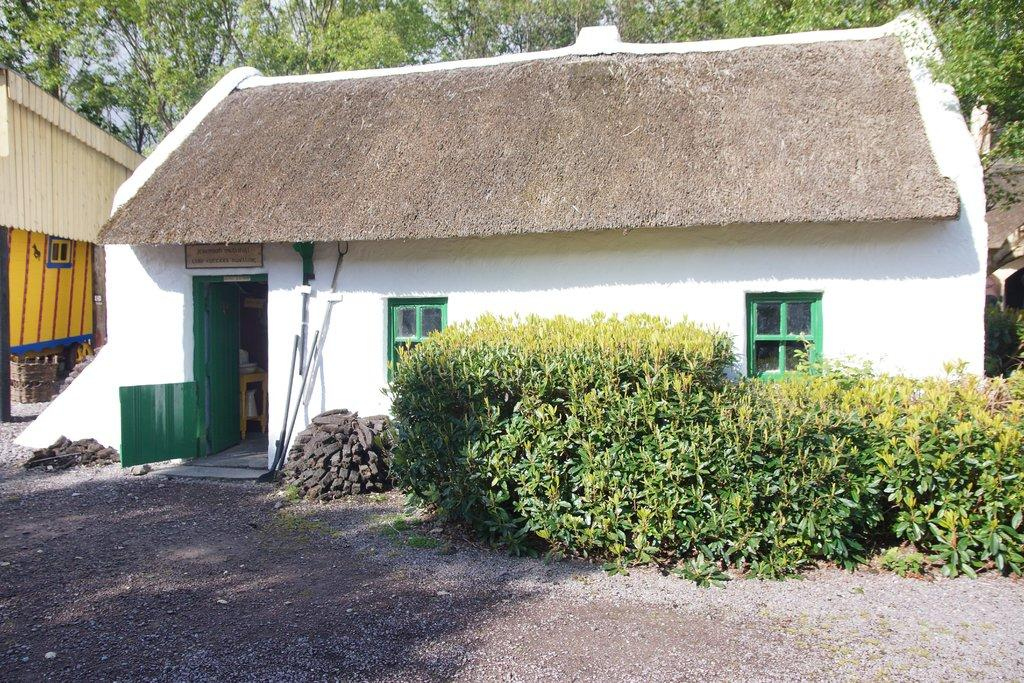What type of structure is visible in the image? There is a house in the image. What features can be seen on the house? The house has windows and a door. What object is present in the image besides the house? There is a board in the image. What type of vegetation is visible in the image? There are plants in the image. What can be seen in the background of the image? There are trees in the background of the image. Can you tell me how many bees are sitting on the door of the house in the image? There are no bees present on the door of the house in the image. What type of store is located near the house in the image? There is no store mentioned or visible in the image. 